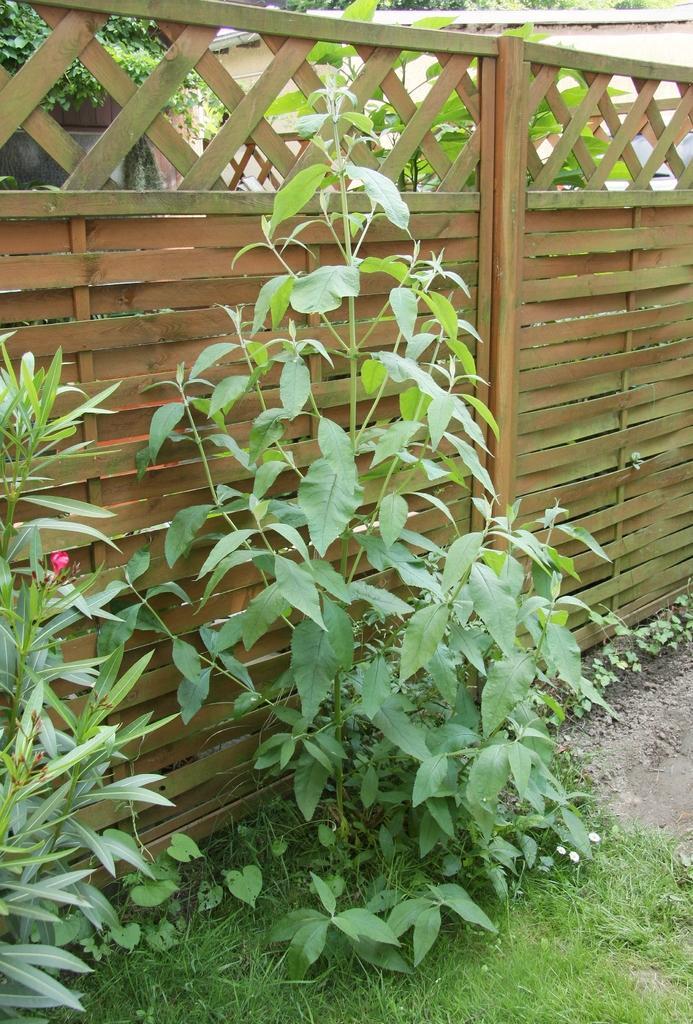In one or two sentences, can you explain what this image depicts? In this picture I can see grass, plants, there is wooden fence, and in the background there are trees. 